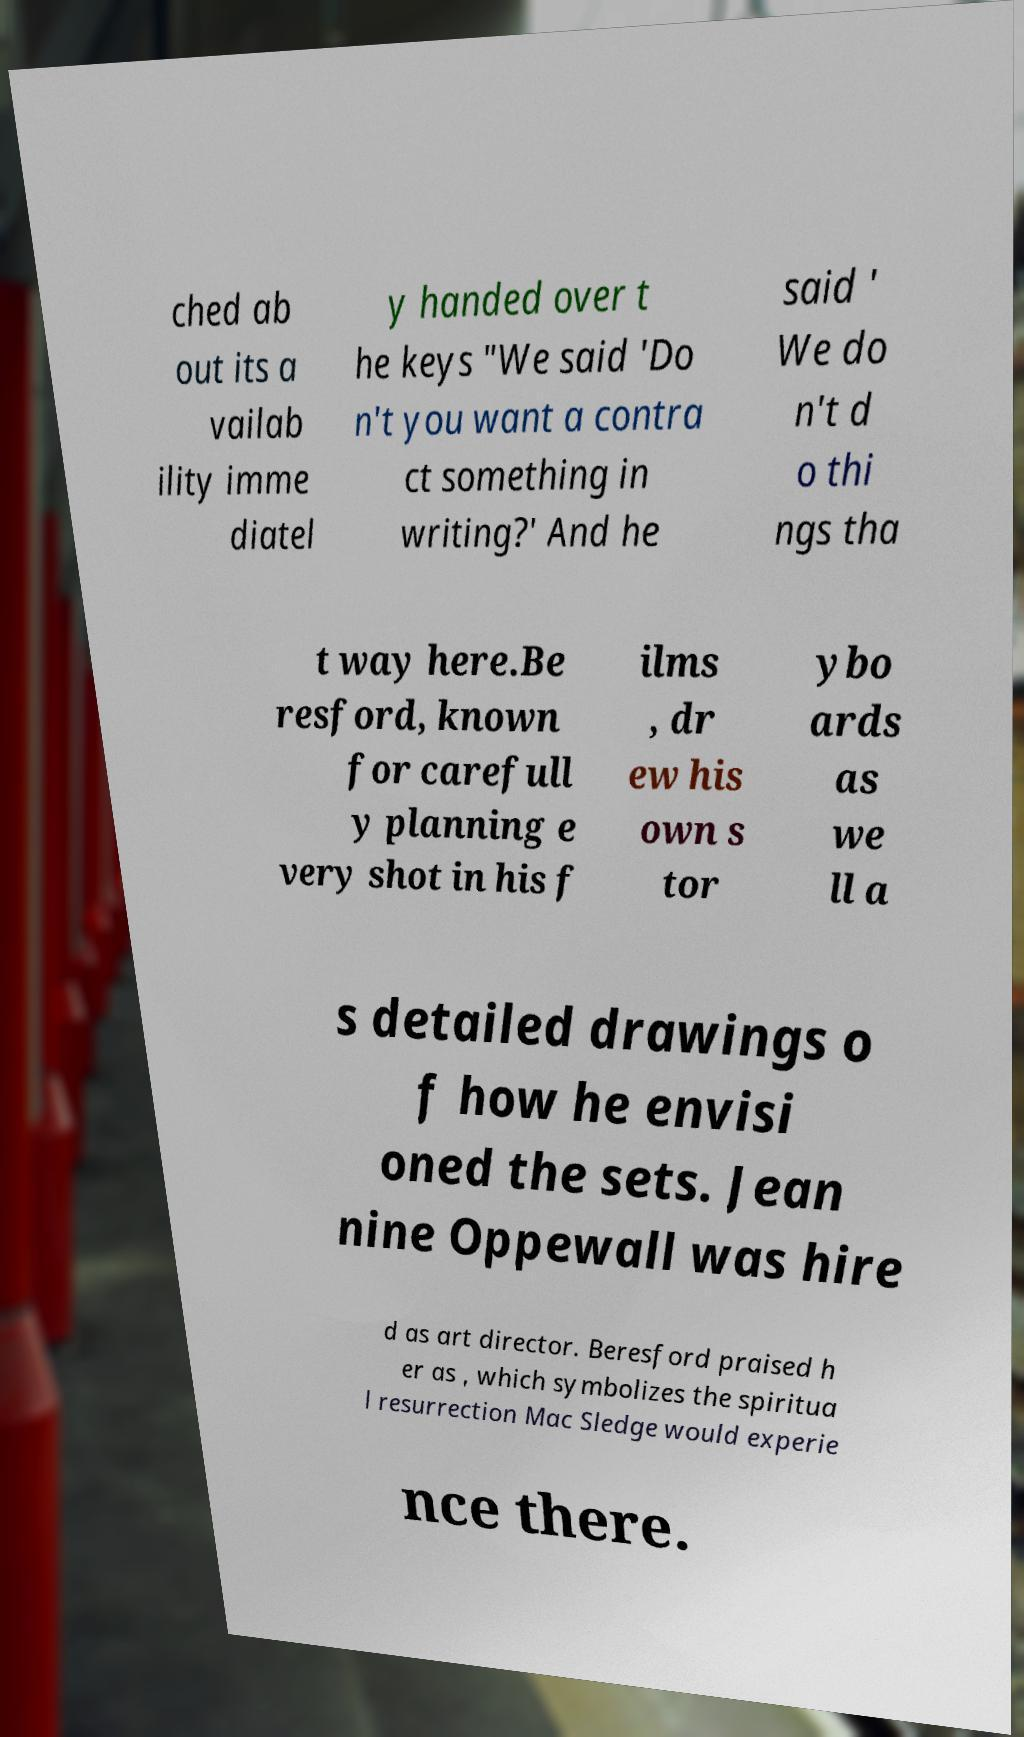Please read and relay the text visible in this image. What does it say? ched ab out its a vailab ility imme diatel y handed over t he keys "We said 'Do n't you want a contra ct something in writing?' And he said ' We do n't d o thi ngs tha t way here.Be resford, known for carefull y planning e very shot in his f ilms , dr ew his own s tor ybo ards as we ll a s detailed drawings o f how he envisi oned the sets. Jean nine Oppewall was hire d as art director. Beresford praised h er as , which symbolizes the spiritua l resurrection Mac Sledge would experie nce there. 